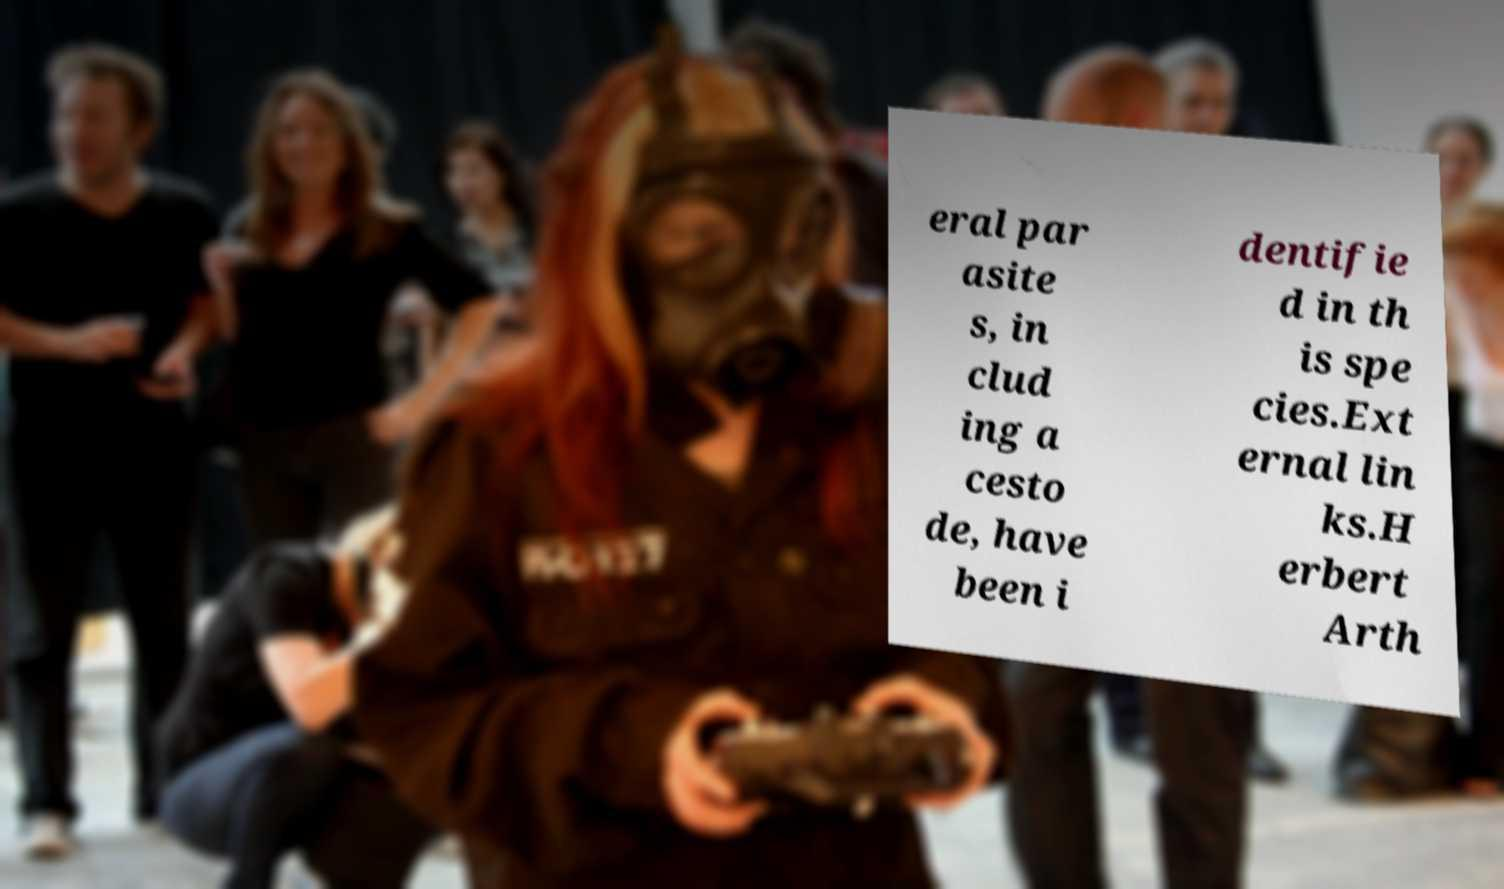Please identify and transcribe the text found in this image. eral par asite s, in clud ing a cesto de, have been i dentifie d in th is spe cies.Ext ernal lin ks.H erbert Arth 